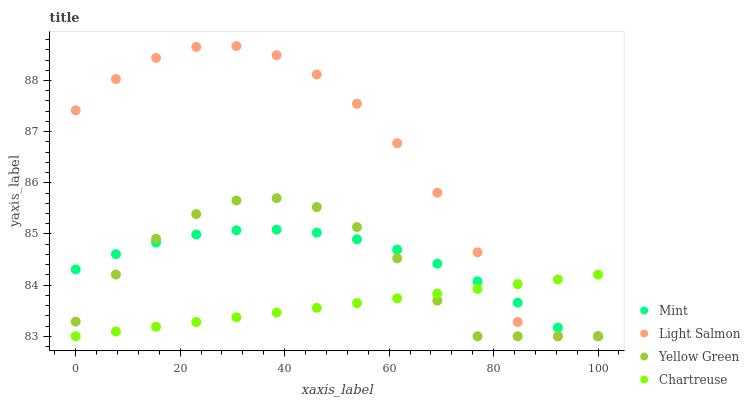Does Chartreuse have the minimum area under the curve?
Answer yes or no. Yes. Does Light Salmon have the maximum area under the curve?
Answer yes or no. Yes. Does Mint have the minimum area under the curve?
Answer yes or no. No. Does Mint have the maximum area under the curve?
Answer yes or no. No. Is Chartreuse the smoothest?
Answer yes or no. Yes. Is Light Salmon the roughest?
Answer yes or no. Yes. Is Mint the smoothest?
Answer yes or no. No. Is Mint the roughest?
Answer yes or no. No. Does Light Salmon have the lowest value?
Answer yes or no. Yes. Does Light Salmon have the highest value?
Answer yes or no. Yes. Does Mint have the highest value?
Answer yes or no. No. Does Yellow Green intersect Mint?
Answer yes or no. Yes. Is Yellow Green less than Mint?
Answer yes or no. No. Is Yellow Green greater than Mint?
Answer yes or no. No. 